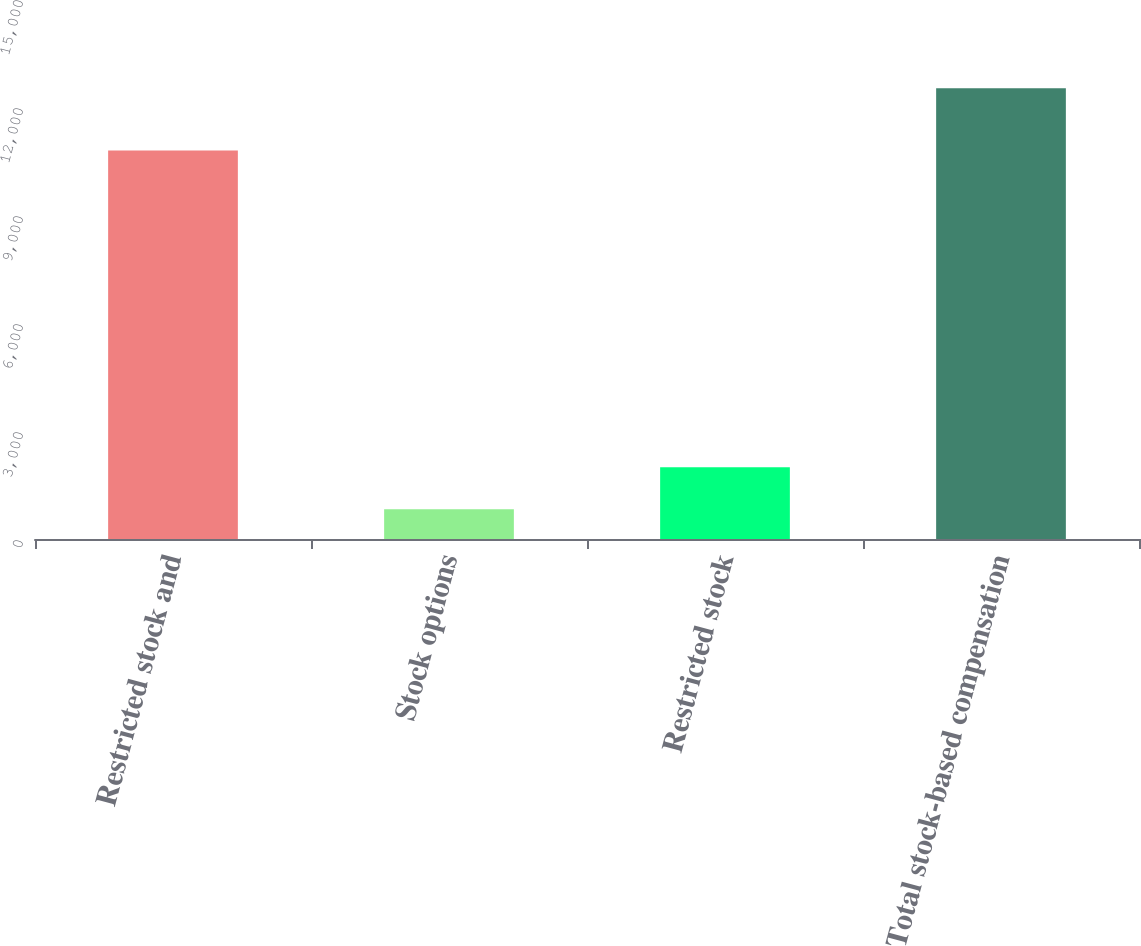Convert chart to OTSL. <chart><loc_0><loc_0><loc_500><loc_500><bar_chart><fcel>Restricted stock and<fcel>Stock options<fcel>Restricted stock<fcel>Total stock-based compensation<nl><fcel>10792<fcel>826<fcel>1995.3<fcel>12519<nl></chart> 